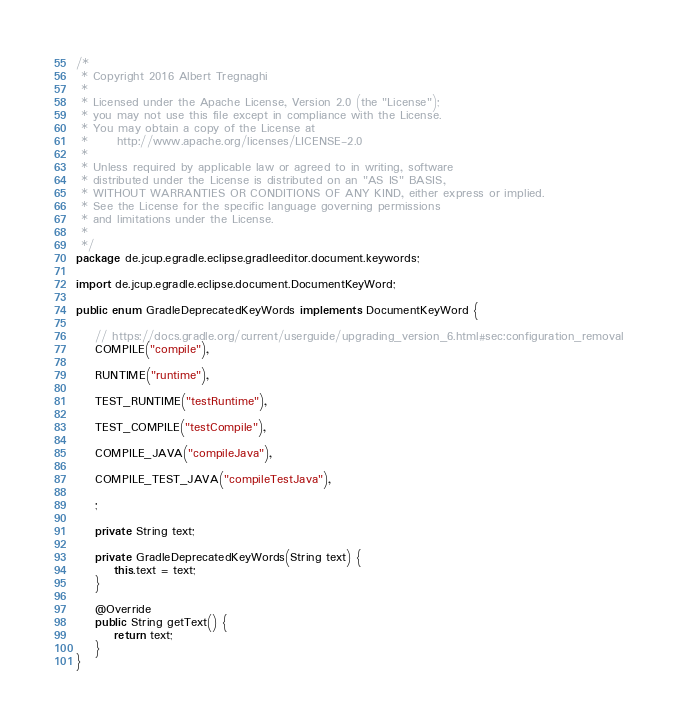<code> <loc_0><loc_0><loc_500><loc_500><_Java_>/*
 * Copyright 2016 Albert Tregnaghi
 *
 * Licensed under the Apache License, Version 2.0 (the "License");
 * you may not use this file except in compliance with the License.
 * You may obtain a copy of the License at
 *		http://www.apache.org/licenses/LICENSE-2.0
 *
 * Unless required by applicable law or agreed to in writing, software
 * distributed under the License is distributed on an "AS IS" BASIS,
 * WITHOUT WARRANTIES OR CONDITIONS OF ANY KIND, either express or implied.
 * See the License for the specific language governing permissions
 * and limitations under the License.
 *
 */
package de.jcup.egradle.eclipse.gradleeditor.document.keywords;

import de.jcup.egradle.eclipse.document.DocumentKeyWord;

public enum GradleDeprecatedKeyWords implements DocumentKeyWord {

    // https://docs.gradle.org/current/userguide/upgrading_version_6.html#sec:configuration_removal
    COMPILE("compile"),

    RUNTIME("runtime"),

    TEST_RUNTIME("testRuntime"),

    TEST_COMPILE("testCompile"),

    COMPILE_JAVA("compileJava"),

    COMPILE_TEST_JAVA("compileTestJava"),

    ;

    private String text;

    private GradleDeprecatedKeyWords(String text) {
        this.text = text;
    }

    @Override
    public String getText() {
        return text;
    }
}
</code> 